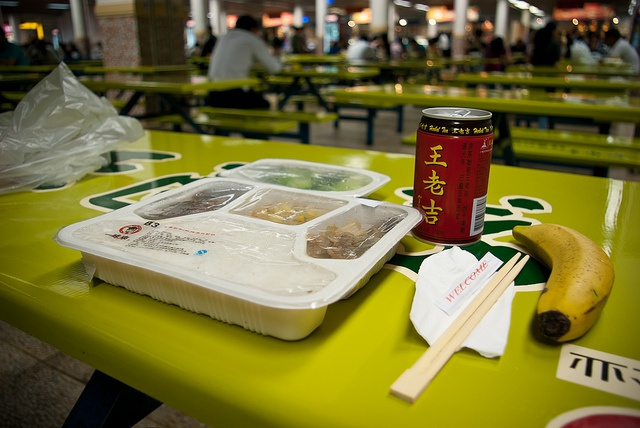Describe the objects in this image and their specific colors. I can see dining table in black, olive, lightgray, and beige tones, banana in black, olive, and tan tones, dining table in black, olive, and darkgreen tones, dining table in black, olive, and gray tones, and people in black, gray, and darkgreen tones in this image. 